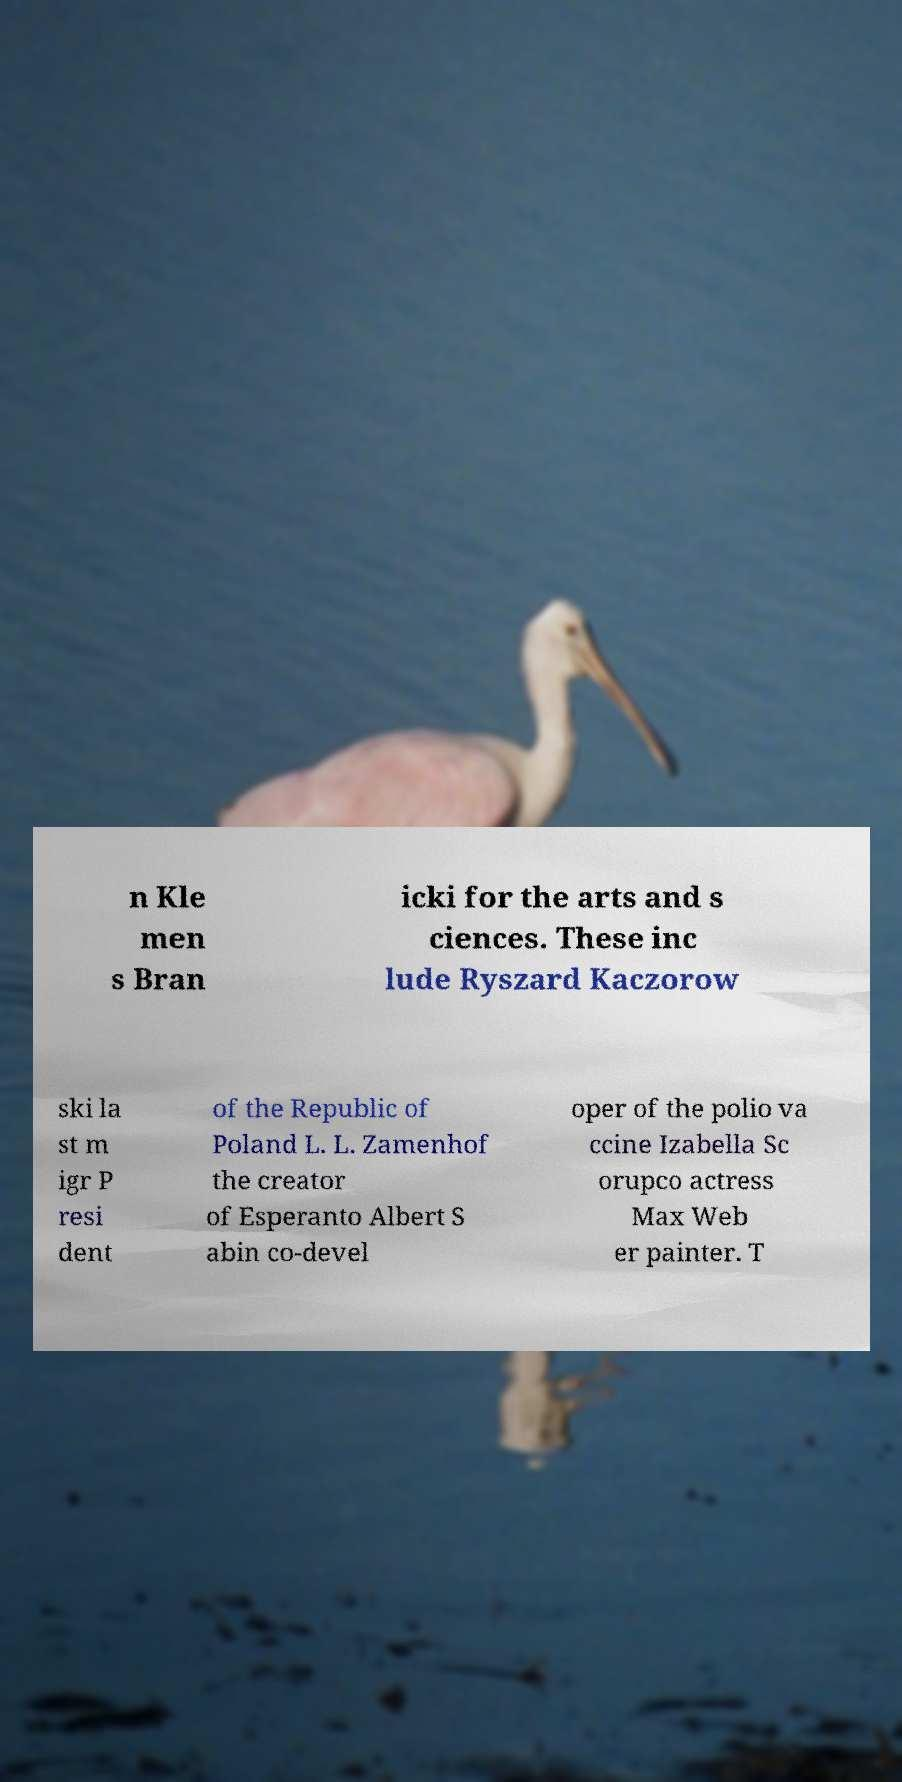Can you accurately transcribe the text from the provided image for me? n Kle men s Bran icki for the arts and s ciences. These inc lude Ryszard Kaczorow ski la st m igr P resi dent of the Republic of Poland L. L. Zamenhof the creator of Esperanto Albert S abin co-devel oper of the polio va ccine Izabella Sc orupco actress Max Web er painter. T 